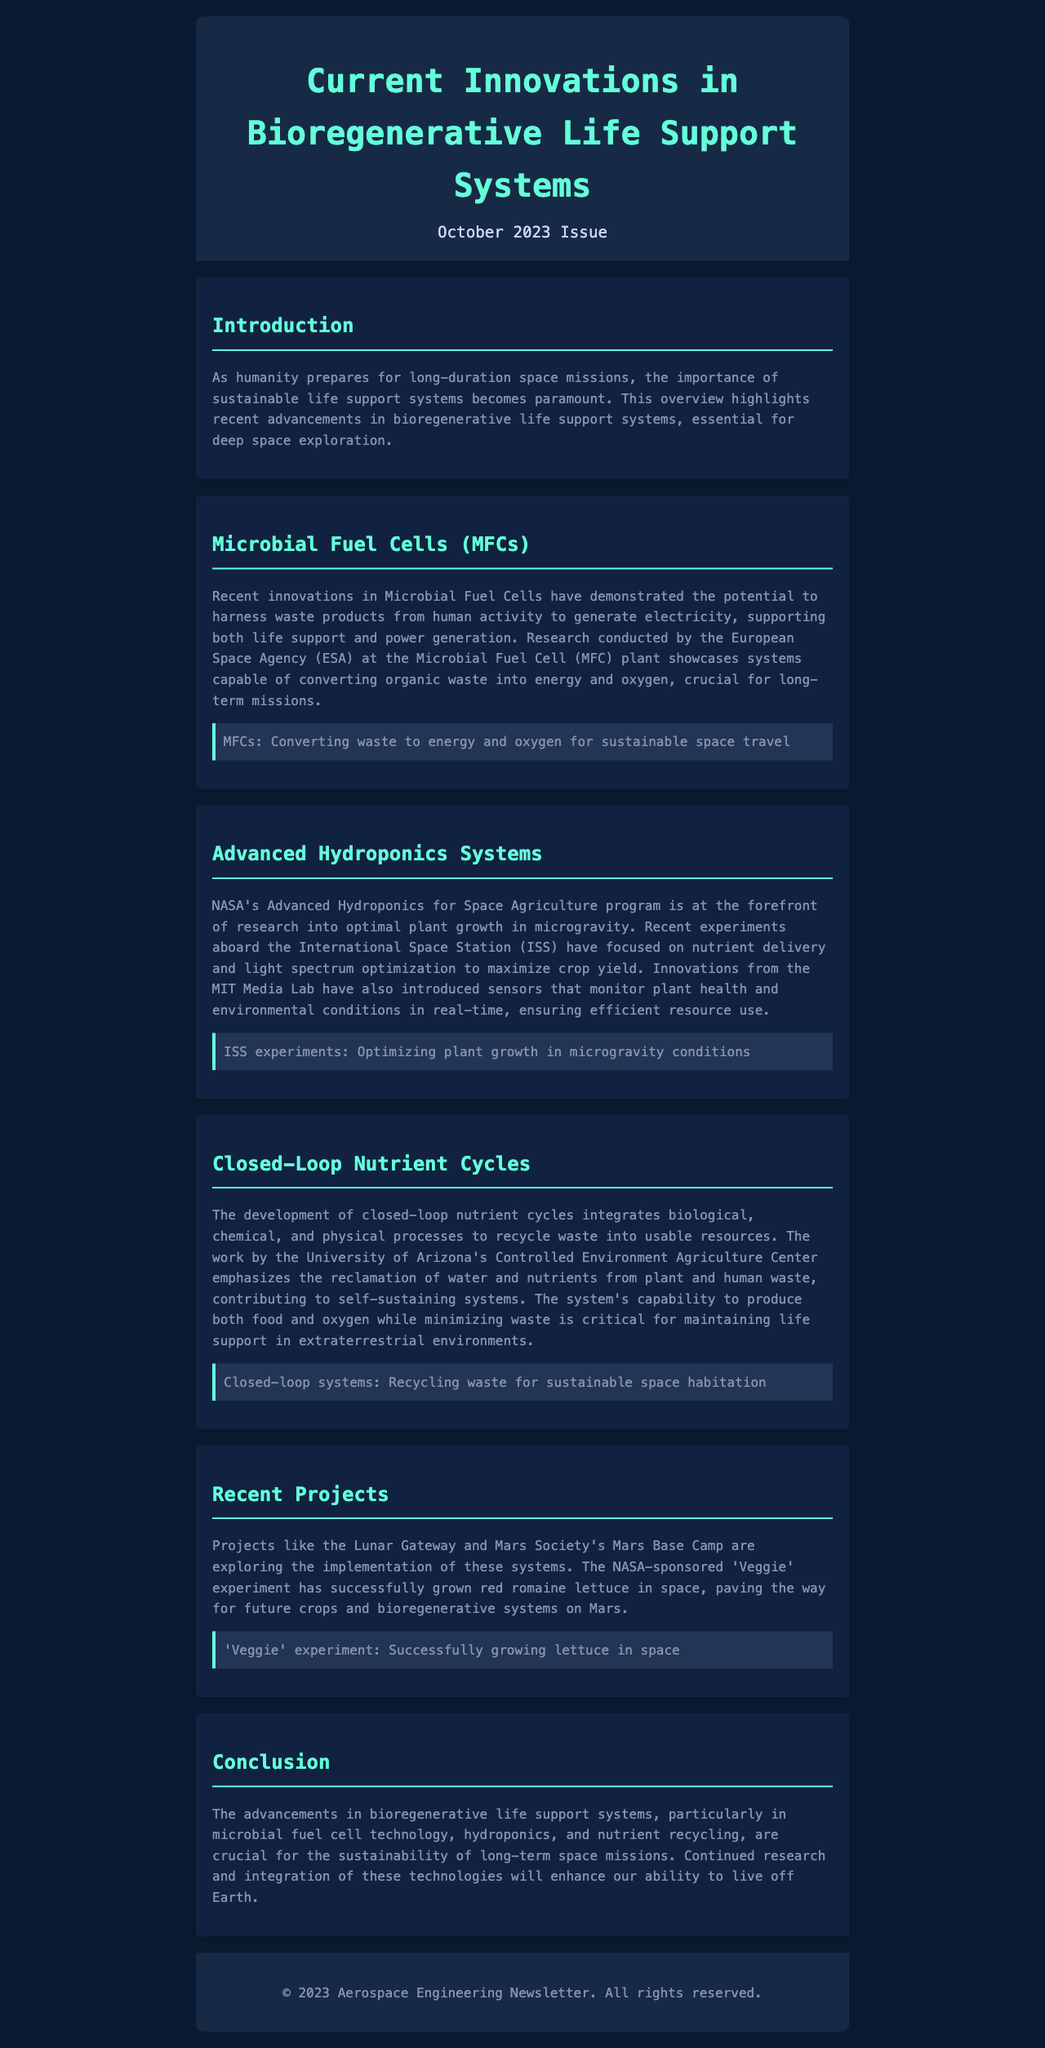What is the title of the newsletter? The title of the newsletter is prominently displayed at the top of the document.
Answer: Current Innovations in Bioregenerative Life Support Systems What month and year is this issue published? The issue date is specified in the header of the newsletter.
Answer: October 2023 What technology is highlighted for converting waste into energy? The document mentions a specific technology focused on energy generation from waste materials.
Answer: Microbial Fuel Cells (MFCs) Which organization has researched optimal plant growth in microgravity? The newsletter refers to a space agency recognized for its research in hydroponics for space agriculture.
Answer: NASA What system is designed to recycle waste into usable resources? The document discusses a system that integrates various processes for resource recycling.
Answer: Closed-Loop Nutrient Cycles What experiment successfully grew lettuce in space? The newsletter highlights a specific project associated with growing crops in a space environment.
Answer: 'Veggie' experiment What is the purpose of the advancements discussed in the newsletter? The conclusion summarizes the overall goal of the innovations mentioned throughout the document.
Answer: Sustainability of long-term space missions 